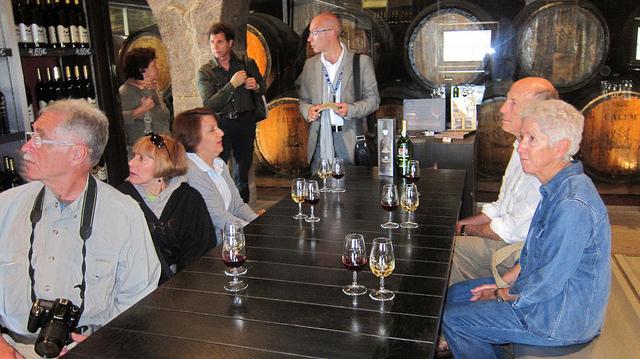What are the tasks in the background likely used for?
Keep it brief. Wine. How many people are wearing glasses?
Keep it brief. 2. What are these people probably drinking?
Give a very brief answer. Wine. 